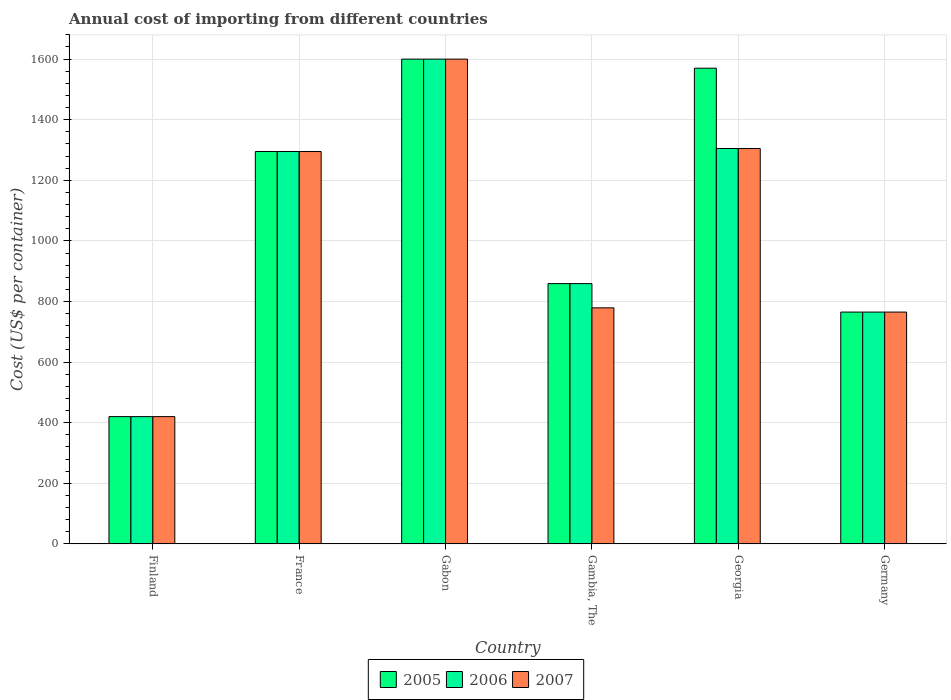How many bars are there on the 6th tick from the left?
Your answer should be very brief. 3. What is the label of the 5th group of bars from the left?
Offer a very short reply. Georgia. In how many cases, is the number of bars for a given country not equal to the number of legend labels?
Provide a succinct answer. 0. What is the total annual cost of importing in 2005 in Finland?
Provide a short and direct response. 420. Across all countries, what is the maximum total annual cost of importing in 2006?
Make the answer very short. 1600. Across all countries, what is the minimum total annual cost of importing in 2006?
Ensure brevity in your answer.  420. In which country was the total annual cost of importing in 2007 maximum?
Provide a short and direct response. Gabon. What is the total total annual cost of importing in 2007 in the graph?
Give a very brief answer. 6164. What is the difference between the total annual cost of importing in 2005 in Gabon and that in Gambia, The?
Ensure brevity in your answer.  741. What is the difference between the total annual cost of importing in 2006 in Gabon and the total annual cost of importing in 2005 in Germany?
Ensure brevity in your answer.  835. What is the average total annual cost of importing in 2007 per country?
Ensure brevity in your answer.  1027.33. What is the difference between the total annual cost of importing of/in 2005 and total annual cost of importing of/in 2007 in Gabon?
Make the answer very short. 0. What is the ratio of the total annual cost of importing in 2007 in France to that in Georgia?
Ensure brevity in your answer.  0.99. Is the total annual cost of importing in 2005 in Gabon less than that in Gambia, The?
Offer a terse response. No. What is the difference between the highest and the second highest total annual cost of importing in 2006?
Ensure brevity in your answer.  295. What is the difference between the highest and the lowest total annual cost of importing in 2007?
Provide a succinct answer. 1180. In how many countries, is the total annual cost of importing in 2006 greater than the average total annual cost of importing in 2006 taken over all countries?
Keep it short and to the point. 3. Is the sum of the total annual cost of importing in 2006 in France and Gambia, The greater than the maximum total annual cost of importing in 2005 across all countries?
Your answer should be very brief. Yes. What does the 2nd bar from the left in Georgia represents?
Your answer should be very brief. 2006. Does the graph contain any zero values?
Your answer should be very brief. No. Does the graph contain grids?
Offer a terse response. Yes. Where does the legend appear in the graph?
Provide a short and direct response. Bottom center. How are the legend labels stacked?
Keep it short and to the point. Horizontal. What is the title of the graph?
Provide a short and direct response. Annual cost of importing from different countries. What is the label or title of the Y-axis?
Your answer should be compact. Cost (US$ per container). What is the Cost (US$ per container) of 2005 in Finland?
Keep it short and to the point. 420. What is the Cost (US$ per container) in 2006 in Finland?
Offer a very short reply. 420. What is the Cost (US$ per container) in 2007 in Finland?
Provide a short and direct response. 420. What is the Cost (US$ per container) of 2005 in France?
Provide a succinct answer. 1295. What is the Cost (US$ per container) in 2006 in France?
Offer a very short reply. 1295. What is the Cost (US$ per container) in 2007 in France?
Give a very brief answer. 1295. What is the Cost (US$ per container) of 2005 in Gabon?
Your response must be concise. 1600. What is the Cost (US$ per container) of 2006 in Gabon?
Your response must be concise. 1600. What is the Cost (US$ per container) in 2007 in Gabon?
Keep it short and to the point. 1600. What is the Cost (US$ per container) in 2005 in Gambia, The?
Provide a succinct answer. 859. What is the Cost (US$ per container) of 2006 in Gambia, The?
Give a very brief answer. 859. What is the Cost (US$ per container) of 2007 in Gambia, The?
Provide a succinct answer. 779. What is the Cost (US$ per container) of 2005 in Georgia?
Your answer should be compact. 1570. What is the Cost (US$ per container) of 2006 in Georgia?
Offer a terse response. 1305. What is the Cost (US$ per container) of 2007 in Georgia?
Provide a short and direct response. 1305. What is the Cost (US$ per container) of 2005 in Germany?
Your answer should be compact. 765. What is the Cost (US$ per container) of 2006 in Germany?
Ensure brevity in your answer.  765. What is the Cost (US$ per container) of 2007 in Germany?
Keep it short and to the point. 765. Across all countries, what is the maximum Cost (US$ per container) in 2005?
Offer a terse response. 1600. Across all countries, what is the maximum Cost (US$ per container) of 2006?
Make the answer very short. 1600. Across all countries, what is the maximum Cost (US$ per container) of 2007?
Your answer should be compact. 1600. Across all countries, what is the minimum Cost (US$ per container) of 2005?
Keep it short and to the point. 420. Across all countries, what is the minimum Cost (US$ per container) of 2006?
Offer a terse response. 420. Across all countries, what is the minimum Cost (US$ per container) in 2007?
Make the answer very short. 420. What is the total Cost (US$ per container) in 2005 in the graph?
Offer a very short reply. 6509. What is the total Cost (US$ per container) of 2006 in the graph?
Make the answer very short. 6244. What is the total Cost (US$ per container) of 2007 in the graph?
Offer a terse response. 6164. What is the difference between the Cost (US$ per container) of 2005 in Finland and that in France?
Offer a terse response. -875. What is the difference between the Cost (US$ per container) in 2006 in Finland and that in France?
Offer a terse response. -875. What is the difference between the Cost (US$ per container) of 2007 in Finland and that in France?
Keep it short and to the point. -875. What is the difference between the Cost (US$ per container) of 2005 in Finland and that in Gabon?
Make the answer very short. -1180. What is the difference between the Cost (US$ per container) in 2006 in Finland and that in Gabon?
Offer a very short reply. -1180. What is the difference between the Cost (US$ per container) in 2007 in Finland and that in Gabon?
Your answer should be compact. -1180. What is the difference between the Cost (US$ per container) in 2005 in Finland and that in Gambia, The?
Your response must be concise. -439. What is the difference between the Cost (US$ per container) of 2006 in Finland and that in Gambia, The?
Offer a terse response. -439. What is the difference between the Cost (US$ per container) of 2007 in Finland and that in Gambia, The?
Keep it short and to the point. -359. What is the difference between the Cost (US$ per container) of 2005 in Finland and that in Georgia?
Your answer should be compact. -1150. What is the difference between the Cost (US$ per container) of 2006 in Finland and that in Georgia?
Your response must be concise. -885. What is the difference between the Cost (US$ per container) in 2007 in Finland and that in Georgia?
Your answer should be very brief. -885. What is the difference between the Cost (US$ per container) of 2005 in Finland and that in Germany?
Give a very brief answer. -345. What is the difference between the Cost (US$ per container) of 2006 in Finland and that in Germany?
Offer a very short reply. -345. What is the difference between the Cost (US$ per container) of 2007 in Finland and that in Germany?
Your answer should be very brief. -345. What is the difference between the Cost (US$ per container) in 2005 in France and that in Gabon?
Make the answer very short. -305. What is the difference between the Cost (US$ per container) of 2006 in France and that in Gabon?
Your answer should be very brief. -305. What is the difference between the Cost (US$ per container) in 2007 in France and that in Gabon?
Make the answer very short. -305. What is the difference between the Cost (US$ per container) of 2005 in France and that in Gambia, The?
Keep it short and to the point. 436. What is the difference between the Cost (US$ per container) of 2006 in France and that in Gambia, The?
Offer a very short reply. 436. What is the difference between the Cost (US$ per container) of 2007 in France and that in Gambia, The?
Make the answer very short. 516. What is the difference between the Cost (US$ per container) of 2005 in France and that in Georgia?
Your answer should be very brief. -275. What is the difference between the Cost (US$ per container) in 2006 in France and that in Georgia?
Offer a very short reply. -10. What is the difference between the Cost (US$ per container) in 2007 in France and that in Georgia?
Keep it short and to the point. -10. What is the difference between the Cost (US$ per container) in 2005 in France and that in Germany?
Offer a very short reply. 530. What is the difference between the Cost (US$ per container) in 2006 in France and that in Germany?
Give a very brief answer. 530. What is the difference between the Cost (US$ per container) of 2007 in France and that in Germany?
Provide a short and direct response. 530. What is the difference between the Cost (US$ per container) of 2005 in Gabon and that in Gambia, The?
Make the answer very short. 741. What is the difference between the Cost (US$ per container) of 2006 in Gabon and that in Gambia, The?
Your answer should be compact. 741. What is the difference between the Cost (US$ per container) in 2007 in Gabon and that in Gambia, The?
Provide a short and direct response. 821. What is the difference between the Cost (US$ per container) of 2005 in Gabon and that in Georgia?
Ensure brevity in your answer.  30. What is the difference between the Cost (US$ per container) of 2006 in Gabon and that in Georgia?
Ensure brevity in your answer.  295. What is the difference between the Cost (US$ per container) of 2007 in Gabon and that in Georgia?
Provide a short and direct response. 295. What is the difference between the Cost (US$ per container) in 2005 in Gabon and that in Germany?
Give a very brief answer. 835. What is the difference between the Cost (US$ per container) of 2006 in Gabon and that in Germany?
Provide a succinct answer. 835. What is the difference between the Cost (US$ per container) of 2007 in Gabon and that in Germany?
Give a very brief answer. 835. What is the difference between the Cost (US$ per container) of 2005 in Gambia, The and that in Georgia?
Keep it short and to the point. -711. What is the difference between the Cost (US$ per container) of 2006 in Gambia, The and that in Georgia?
Give a very brief answer. -446. What is the difference between the Cost (US$ per container) in 2007 in Gambia, The and that in Georgia?
Provide a succinct answer. -526. What is the difference between the Cost (US$ per container) in 2005 in Gambia, The and that in Germany?
Your answer should be very brief. 94. What is the difference between the Cost (US$ per container) of 2006 in Gambia, The and that in Germany?
Offer a very short reply. 94. What is the difference between the Cost (US$ per container) in 2005 in Georgia and that in Germany?
Give a very brief answer. 805. What is the difference between the Cost (US$ per container) in 2006 in Georgia and that in Germany?
Offer a terse response. 540. What is the difference between the Cost (US$ per container) in 2007 in Georgia and that in Germany?
Your answer should be very brief. 540. What is the difference between the Cost (US$ per container) in 2005 in Finland and the Cost (US$ per container) in 2006 in France?
Provide a short and direct response. -875. What is the difference between the Cost (US$ per container) in 2005 in Finland and the Cost (US$ per container) in 2007 in France?
Provide a short and direct response. -875. What is the difference between the Cost (US$ per container) of 2006 in Finland and the Cost (US$ per container) of 2007 in France?
Provide a succinct answer. -875. What is the difference between the Cost (US$ per container) in 2005 in Finland and the Cost (US$ per container) in 2006 in Gabon?
Offer a terse response. -1180. What is the difference between the Cost (US$ per container) of 2005 in Finland and the Cost (US$ per container) of 2007 in Gabon?
Ensure brevity in your answer.  -1180. What is the difference between the Cost (US$ per container) in 2006 in Finland and the Cost (US$ per container) in 2007 in Gabon?
Offer a very short reply. -1180. What is the difference between the Cost (US$ per container) of 2005 in Finland and the Cost (US$ per container) of 2006 in Gambia, The?
Your response must be concise. -439. What is the difference between the Cost (US$ per container) of 2005 in Finland and the Cost (US$ per container) of 2007 in Gambia, The?
Give a very brief answer. -359. What is the difference between the Cost (US$ per container) in 2006 in Finland and the Cost (US$ per container) in 2007 in Gambia, The?
Give a very brief answer. -359. What is the difference between the Cost (US$ per container) in 2005 in Finland and the Cost (US$ per container) in 2006 in Georgia?
Ensure brevity in your answer.  -885. What is the difference between the Cost (US$ per container) in 2005 in Finland and the Cost (US$ per container) in 2007 in Georgia?
Provide a succinct answer. -885. What is the difference between the Cost (US$ per container) of 2006 in Finland and the Cost (US$ per container) of 2007 in Georgia?
Keep it short and to the point. -885. What is the difference between the Cost (US$ per container) of 2005 in Finland and the Cost (US$ per container) of 2006 in Germany?
Your answer should be compact. -345. What is the difference between the Cost (US$ per container) of 2005 in Finland and the Cost (US$ per container) of 2007 in Germany?
Offer a terse response. -345. What is the difference between the Cost (US$ per container) in 2006 in Finland and the Cost (US$ per container) in 2007 in Germany?
Offer a very short reply. -345. What is the difference between the Cost (US$ per container) of 2005 in France and the Cost (US$ per container) of 2006 in Gabon?
Provide a short and direct response. -305. What is the difference between the Cost (US$ per container) in 2005 in France and the Cost (US$ per container) in 2007 in Gabon?
Ensure brevity in your answer.  -305. What is the difference between the Cost (US$ per container) of 2006 in France and the Cost (US$ per container) of 2007 in Gabon?
Ensure brevity in your answer.  -305. What is the difference between the Cost (US$ per container) in 2005 in France and the Cost (US$ per container) in 2006 in Gambia, The?
Offer a terse response. 436. What is the difference between the Cost (US$ per container) in 2005 in France and the Cost (US$ per container) in 2007 in Gambia, The?
Your answer should be compact. 516. What is the difference between the Cost (US$ per container) of 2006 in France and the Cost (US$ per container) of 2007 in Gambia, The?
Provide a short and direct response. 516. What is the difference between the Cost (US$ per container) in 2005 in France and the Cost (US$ per container) in 2007 in Georgia?
Offer a terse response. -10. What is the difference between the Cost (US$ per container) of 2005 in France and the Cost (US$ per container) of 2006 in Germany?
Ensure brevity in your answer.  530. What is the difference between the Cost (US$ per container) in 2005 in France and the Cost (US$ per container) in 2007 in Germany?
Give a very brief answer. 530. What is the difference between the Cost (US$ per container) of 2006 in France and the Cost (US$ per container) of 2007 in Germany?
Provide a succinct answer. 530. What is the difference between the Cost (US$ per container) in 2005 in Gabon and the Cost (US$ per container) in 2006 in Gambia, The?
Your answer should be very brief. 741. What is the difference between the Cost (US$ per container) in 2005 in Gabon and the Cost (US$ per container) in 2007 in Gambia, The?
Offer a very short reply. 821. What is the difference between the Cost (US$ per container) in 2006 in Gabon and the Cost (US$ per container) in 2007 in Gambia, The?
Offer a very short reply. 821. What is the difference between the Cost (US$ per container) in 2005 in Gabon and the Cost (US$ per container) in 2006 in Georgia?
Your answer should be compact. 295. What is the difference between the Cost (US$ per container) in 2005 in Gabon and the Cost (US$ per container) in 2007 in Georgia?
Provide a succinct answer. 295. What is the difference between the Cost (US$ per container) in 2006 in Gabon and the Cost (US$ per container) in 2007 in Georgia?
Provide a succinct answer. 295. What is the difference between the Cost (US$ per container) in 2005 in Gabon and the Cost (US$ per container) in 2006 in Germany?
Offer a very short reply. 835. What is the difference between the Cost (US$ per container) of 2005 in Gabon and the Cost (US$ per container) of 2007 in Germany?
Ensure brevity in your answer.  835. What is the difference between the Cost (US$ per container) in 2006 in Gabon and the Cost (US$ per container) in 2007 in Germany?
Make the answer very short. 835. What is the difference between the Cost (US$ per container) of 2005 in Gambia, The and the Cost (US$ per container) of 2006 in Georgia?
Keep it short and to the point. -446. What is the difference between the Cost (US$ per container) in 2005 in Gambia, The and the Cost (US$ per container) in 2007 in Georgia?
Your response must be concise. -446. What is the difference between the Cost (US$ per container) in 2006 in Gambia, The and the Cost (US$ per container) in 2007 in Georgia?
Keep it short and to the point. -446. What is the difference between the Cost (US$ per container) in 2005 in Gambia, The and the Cost (US$ per container) in 2006 in Germany?
Offer a very short reply. 94. What is the difference between the Cost (US$ per container) in 2005 in Gambia, The and the Cost (US$ per container) in 2007 in Germany?
Your answer should be compact. 94. What is the difference between the Cost (US$ per container) of 2006 in Gambia, The and the Cost (US$ per container) of 2007 in Germany?
Your answer should be compact. 94. What is the difference between the Cost (US$ per container) in 2005 in Georgia and the Cost (US$ per container) in 2006 in Germany?
Ensure brevity in your answer.  805. What is the difference between the Cost (US$ per container) in 2005 in Georgia and the Cost (US$ per container) in 2007 in Germany?
Your answer should be very brief. 805. What is the difference between the Cost (US$ per container) in 2006 in Georgia and the Cost (US$ per container) in 2007 in Germany?
Offer a terse response. 540. What is the average Cost (US$ per container) in 2005 per country?
Offer a very short reply. 1084.83. What is the average Cost (US$ per container) of 2006 per country?
Provide a succinct answer. 1040.67. What is the average Cost (US$ per container) of 2007 per country?
Provide a succinct answer. 1027.33. What is the difference between the Cost (US$ per container) of 2005 and Cost (US$ per container) of 2006 in Finland?
Give a very brief answer. 0. What is the difference between the Cost (US$ per container) of 2005 and Cost (US$ per container) of 2007 in Finland?
Offer a very short reply. 0. What is the difference between the Cost (US$ per container) of 2006 and Cost (US$ per container) of 2007 in Finland?
Your response must be concise. 0. What is the difference between the Cost (US$ per container) in 2005 and Cost (US$ per container) in 2006 in France?
Keep it short and to the point. 0. What is the difference between the Cost (US$ per container) of 2005 and Cost (US$ per container) of 2007 in France?
Offer a very short reply. 0. What is the difference between the Cost (US$ per container) of 2005 and Cost (US$ per container) of 2006 in Gabon?
Offer a very short reply. 0. What is the difference between the Cost (US$ per container) of 2005 and Cost (US$ per container) of 2007 in Gabon?
Ensure brevity in your answer.  0. What is the difference between the Cost (US$ per container) of 2005 and Cost (US$ per container) of 2006 in Gambia, The?
Give a very brief answer. 0. What is the difference between the Cost (US$ per container) of 2006 and Cost (US$ per container) of 2007 in Gambia, The?
Make the answer very short. 80. What is the difference between the Cost (US$ per container) in 2005 and Cost (US$ per container) in 2006 in Georgia?
Provide a succinct answer. 265. What is the difference between the Cost (US$ per container) in 2005 and Cost (US$ per container) in 2007 in Georgia?
Keep it short and to the point. 265. What is the difference between the Cost (US$ per container) in 2006 and Cost (US$ per container) in 2007 in Georgia?
Your answer should be very brief. 0. What is the difference between the Cost (US$ per container) in 2005 and Cost (US$ per container) in 2007 in Germany?
Offer a terse response. 0. What is the difference between the Cost (US$ per container) of 2006 and Cost (US$ per container) of 2007 in Germany?
Your answer should be compact. 0. What is the ratio of the Cost (US$ per container) in 2005 in Finland to that in France?
Your answer should be compact. 0.32. What is the ratio of the Cost (US$ per container) in 2006 in Finland to that in France?
Keep it short and to the point. 0.32. What is the ratio of the Cost (US$ per container) in 2007 in Finland to that in France?
Provide a succinct answer. 0.32. What is the ratio of the Cost (US$ per container) of 2005 in Finland to that in Gabon?
Your response must be concise. 0.26. What is the ratio of the Cost (US$ per container) of 2006 in Finland to that in Gabon?
Provide a succinct answer. 0.26. What is the ratio of the Cost (US$ per container) of 2007 in Finland to that in Gabon?
Give a very brief answer. 0.26. What is the ratio of the Cost (US$ per container) in 2005 in Finland to that in Gambia, The?
Your answer should be compact. 0.49. What is the ratio of the Cost (US$ per container) in 2006 in Finland to that in Gambia, The?
Offer a very short reply. 0.49. What is the ratio of the Cost (US$ per container) in 2007 in Finland to that in Gambia, The?
Your answer should be very brief. 0.54. What is the ratio of the Cost (US$ per container) in 2005 in Finland to that in Georgia?
Give a very brief answer. 0.27. What is the ratio of the Cost (US$ per container) of 2006 in Finland to that in Georgia?
Make the answer very short. 0.32. What is the ratio of the Cost (US$ per container) in 2007 in Finland to that in Georgia?
Offer a terse response. 0.32. What is the ratio of the Cost (US$ per container) of 2005 in Finland to that in Germany?
Provide a short and direct response. 0.55. What is the ratio of the Cost (US$ per container) in 2006 in Finland to that in Germany?
Offer a terse response. 0.55. What is the ratio of the Cost (US$ per container) in 2007 in Finland to that in Germany?
Your answer should be very brief. 0.55. What is the ratio of the Cost (US$ per container) of 2005 in France to that in Gabon?
Ensure brevity in your answer.  0.81. What is the ratio of the Cost (US$ per container) of 2006 in France to that in Gabon?
Your answer should be very brief. 0.81. What is the ratio of the Cost (US$ per container) of 2007 in France to that in Gabon?
Your answer should be very brief. 0.81. What is the ratio of the Cost (US$ per container) of 2005 in France to that in Gambia, The?
Provide a succinct answer. 1.51. What is the ratio of the Cost (US$ per container) of 2006 in France to that in Gambia, The?
Offer a terse response. 1.51. What is the ratio of the Cost (US$ per container) of 2007 in France to that in Gambia, The?
Give a very brief answer. 1.66. What is the ratio of the Cost (US$ per container) of 2005 in France to that in Georgia?
Provide a short and direct response. 0.82. What is the ratio of the Cost (US$ per container) in 2006 in France to that in Georgia?
Provide a short and direct response. 0.99. What is the ratio of the Cost (US$ per container) of 2005 in France to that in Germany?
Offer a terse response. 1.69. What is the ratio of the Cost (US$ per container) of 2006 in France to that in Germany?
Your response must be concise. 1.69. What is the ratio of the Cost (US$ per container) of 2007 in France to that in Germany?
Offer a terse response. 1.69. What is the ratio of the Cost (US$ per container) in 2005 in Gabon to that in Gambia, The?
Make the answer very short. 1.86. What is the ratio of the Cost (US$ per container) of 2006 in Gabon to that in Gambia, The?
Keep it short and to the point. 1.86. What is the ratio of the Cost (US$ per container) of 2007 in Gabon to that in Gambia, The?
Offer a terse response. 2.05. What is the ratio of the Cost (US$ per container) in 2005 in Gabon to that in Georgia?
Give a very brief answer. 1.02. What is the ratio of the Cost (US$ per container) of 2006 in Gabon to that in Georgia?
Offer a very short reply. 1.23. What is the ratio of the Cost (US$ per container) in 2007 in Gabon to that in Georgia?
Offer a very short reply. 1.23. What is the ratio of the Cost (US$ per container) of 2005 in Gabon to that in Germany?
Your response must be concise. 2.09. What is the ratio of the Cost (US$ per container) of 2006 in Gabon to that in Germany?
Give a very brief answer. 2.09. What is the ratio of the Cost (US$ per container) in 2007 in Gabon to that in Germany?
Offer a very short reply. 2.09. What is the ratio of the Cost (US$ per container) in 2005 in Gambia, The to that in Georgia?
Keep it short and to the point. 0.55. What is the ratio of the Cost (US$ per container) of 2006 in Gambia, The to that in Georgia?
Your response must be concise. 0.66. What is the ratio of the Cost (US$ per container) in 2007 in Gambia, The to that in Georgia?
Keep it short and to the point. 0.6. What is the ratio of the Cost (US$ per container) in 2005 in Gambia, The to that in Germany?
Keep it short and to the point. 1.12. What is the ratio of the Cost (US$ per container) of 2006 in Gambia, The to that in Germany?
Offer a very short reply. 1.12. What is the ratio of the Cost (US$ per container) of 2007 in Gambia, The to that in Germany?
Your answer should be compact. 1.02. What is the ratio of the Cost (US$ per container) of 2005 in Georgia to that in Germany?
Keep it short and to the point. 2.05. What is the ratio of the Cost (US$ per container) of 2006 in Georgia to that in Germany?
Your response must be concise. 1.71. What is the ratio of the Cost (US$ per container) in 2007 in Georgia to that in Germany?
Provide a succinct answer. 1.71. What is the difference between the highest and the second highest Cost (US$ per container) in 2005?
Your answer should be very brief. 30. What is the difference between the highest and the second highest Cost (US$ per container) of 2006?
Offer a very short reply. 295. What is the difference between the highest and the second highest Cost (US$ per container) in 2007?
Give a very brief answer. 295. What is the difference between the highest and the lowest Cost (US$ per container) in 2005?
Provide a succinct answer. 1180. What is the difference between the highest and the lowest Cost (US$ per container) of 2006?
Ensure brevity in your answer.  1180. What is the difference between the highest and the lowest Cost (US$ per container) of 2007?
Your answer should be very brief. 1180. 